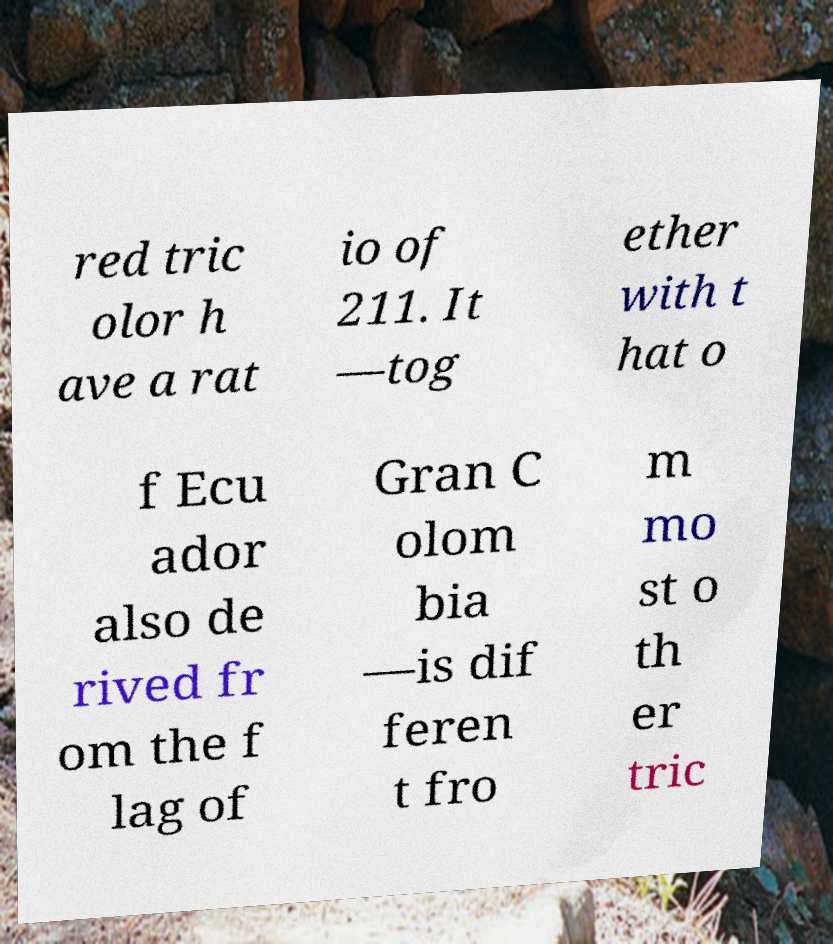Can you accurately transcribe the text from the provided image for me? red tric olor h ave a rat io of 211. It —tog ether with t hat o f Ecu ador also de rived fr om the f lag of Gran C olom bia —is dif feren t fro m mo st o th er tric 